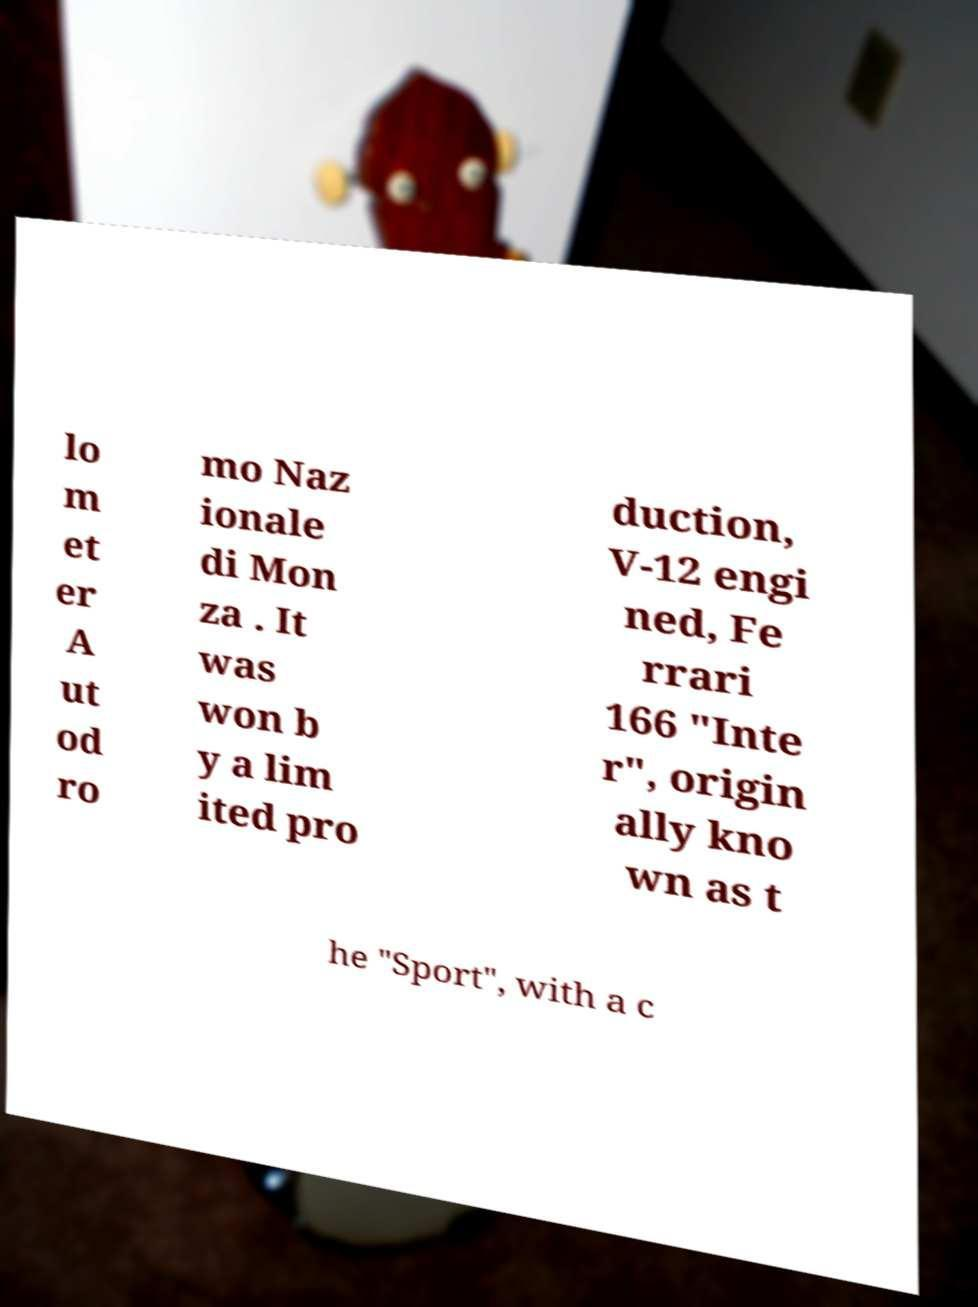Could you extract and type out the text from this image? lo m et er A ut od ro mo Naz ionale di Mon za . It was won b y a lim ited pro duction, V-12 engi ned, Fe rrari 166 "Inte r", origin ally kno wn as t he "Sport", with a c 